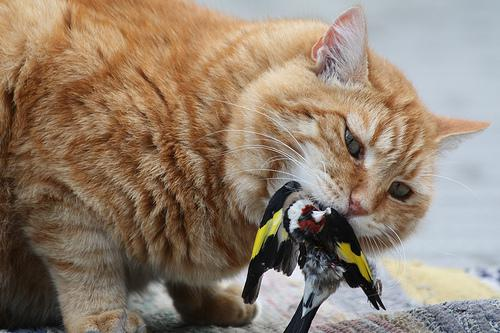Question: what is in the cat's mouth?
Choices:
A. Bird.
B. Rat.
C. Mice.
D. Bug.
Answer with the letter. Answer: A Question: how does the cat look?
Choices:
A. Fluffy.
B. Big.
C. Small.
D. Fat.
Answer with the letter. Answer: B Question: what is the cat doing?
Choices:
A. Drinking.
B. Licking.
C. Sleeping.
D. Eating.
Answer with the letter. Answer: D Question: what kind of cat is that?
Choices:
A. Tabby.
B. Persian.
C. Siamese.
D. Short hair.
Answer with the letter. Answer: A Question: what time of day is it?
Choices:
A. Morning.
B. Afternoon.
C. Night.
D. Evening.
Answer with the letter. Answer: A Question: what color is the cat?
Choices:
A. Black.
B. Orange.
C. Brown.
D. Grey.
Answer with the letter. Answer: B 